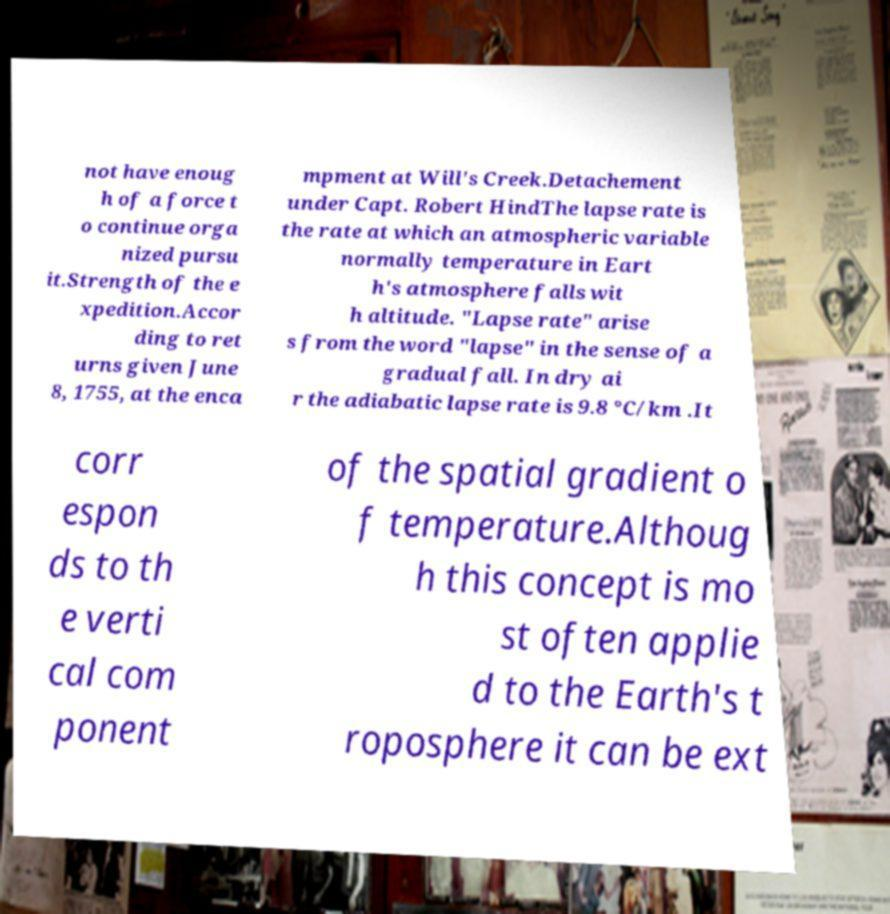Could you extract and type out the text from this image? not have enoug h of a force t o continue orga nized pursu it.Strength of the e xpedition.Accor ding to ret urns given June 8, 1755, at the enca mpment at Will's Creek.Detachement under Capt. Robert HindThe lapse rate is the rate at which an atmospheric variable normally temperature in Eart h's atmosphere falls wit h altitude. "Lapse rate" arise s from the word "lapse" in the sense of a gradual fall. In dry ai r the adiabatic lapse rate is 9.8 °C/km .It corr espon ds to th e verti cal com ponent of the spatial gradient o f temperature.Althoug h this concept is mo st often applie d to the Earth's t roposphere it can be ext 